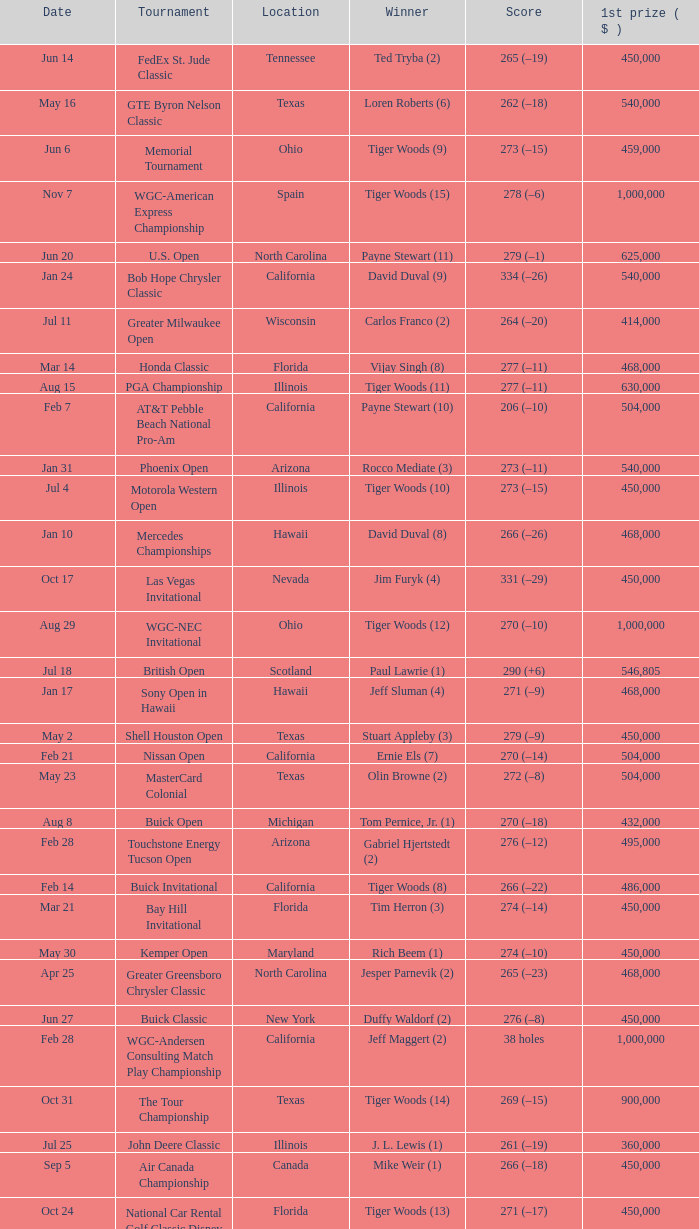What is the score of the B.C. Open in New York? 273 (–15). 